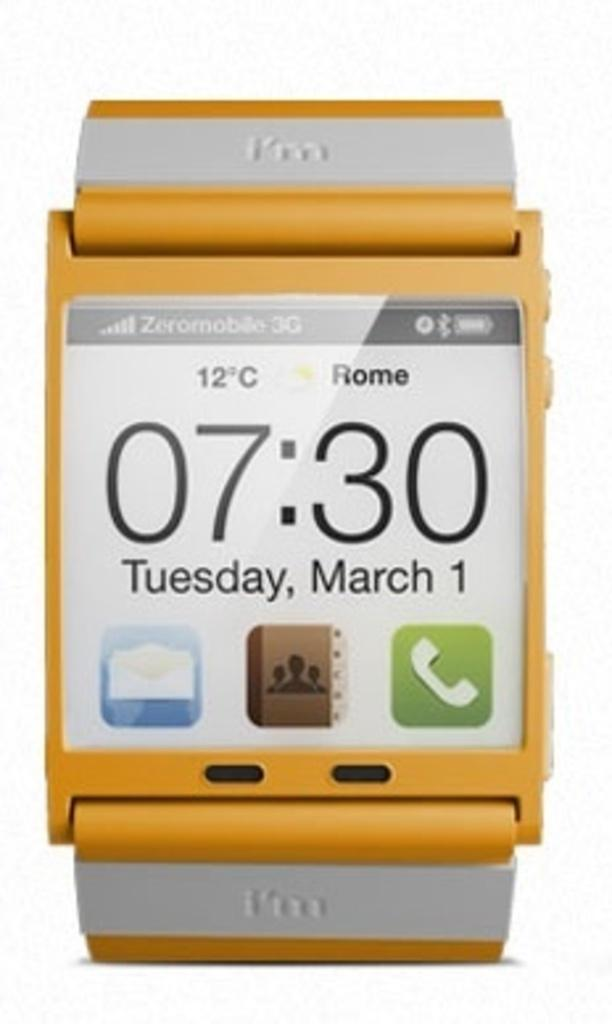Provide a one-sentence caption for the provided image. watch which displays the time of 7:30 tuesday march 1st. 